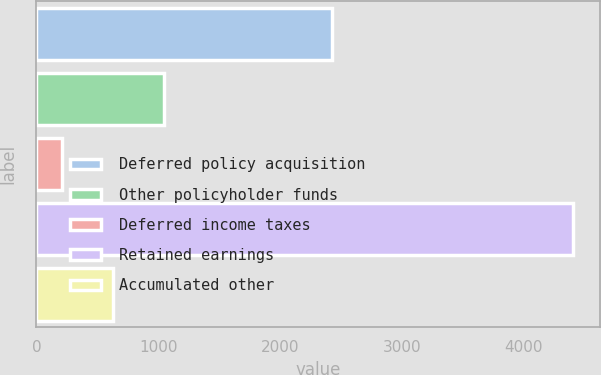Convert chart. <chart><loc_0><loc_0><loc_500><loc_500><bar_chart><fcel>Deferred policy acquisition<fcel>Other policyholder funds<fcel>Deferred income taxes<fcel>Retained earnings<fcel>Accumulated other<nl><fcel>2428<fcel>1047.42<fcel>208.7<fcel>4402.3<fcel>628.06<nl></chart> 